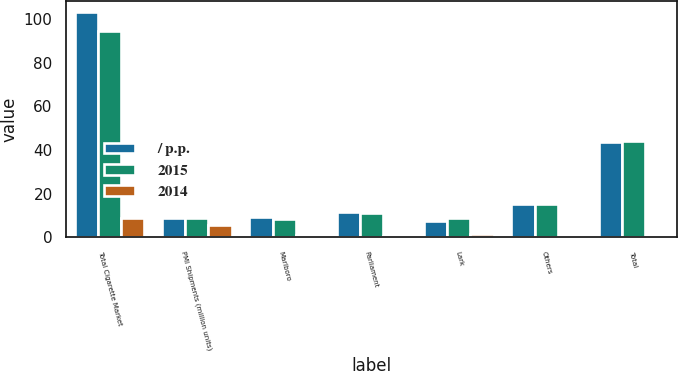Convert chart to OTSL. <chart><loc_0><loc_0><loc_500><loc_500><stacked_bar_chart><ecel><fcel>Total Cigarette Market<fcel>PMI Shipments (million units)<fcel>Marlboro<fcel>Parliament<fcel>Lark<fcel>Others<fcel>Total<nl><fcel>/ p.p.<fcel>103.2<fcel>9<fcel>9.5<fcel>11.6<fcel>7.6<fcel>15.1<fcel>43.8<nl><fcel>2015<fcel>94.7<fcel>9<fcel>8.6<fcel>11.2<fcel>9<fcel>15.2<fcel>44<nl><fcel>2014<fcel>9<fcel>5.8<fcel>0.9<fcel>0.4<fcel>1.4<fcel>0.1<fcel>0.2<nl></chart> 